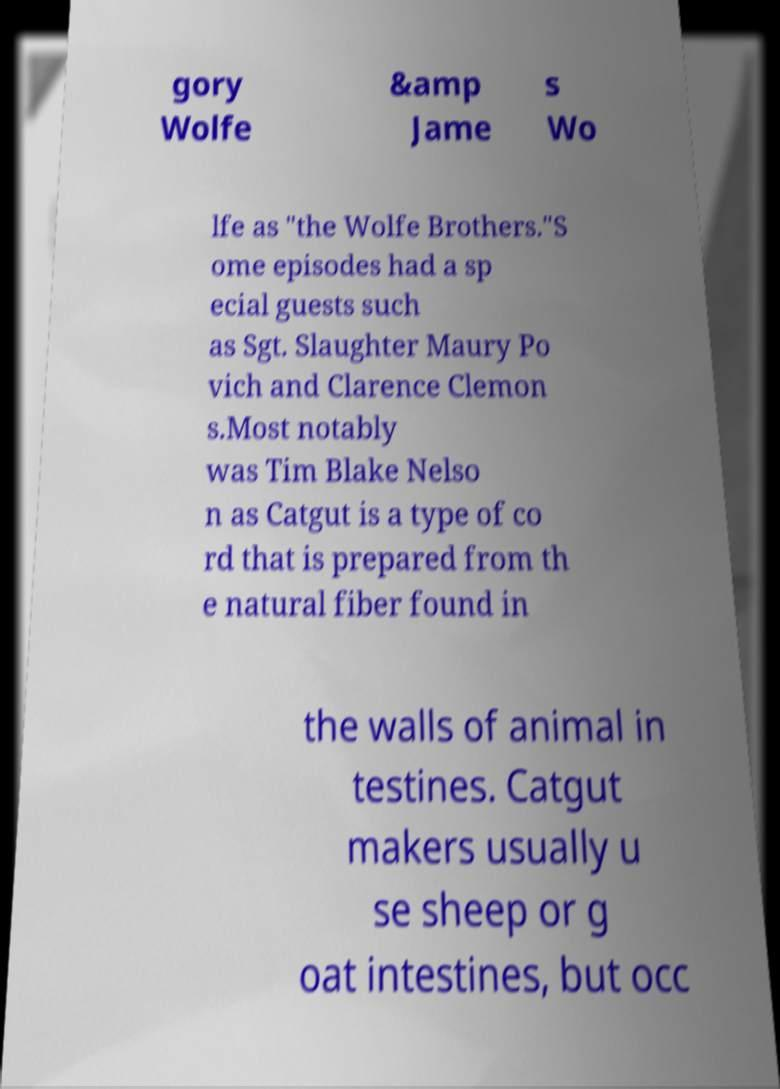What messages or text are displayed in this image? I need them in a readable, typed format. gory Wolfe &amp Jame s Wo lfe as "the Wolfe Brothers."S ome episodes had a sp ecial guests such as Sgt. Slaughter Maury Po vich and Clarence Clemon s.Most notably was Tim Blake Nelso n as Catgut is a type of co rd that is prepared from th e natural fiber found in the walls of animal in testines. Catgut makers usually u se sheep or g oat intestines, but occ 